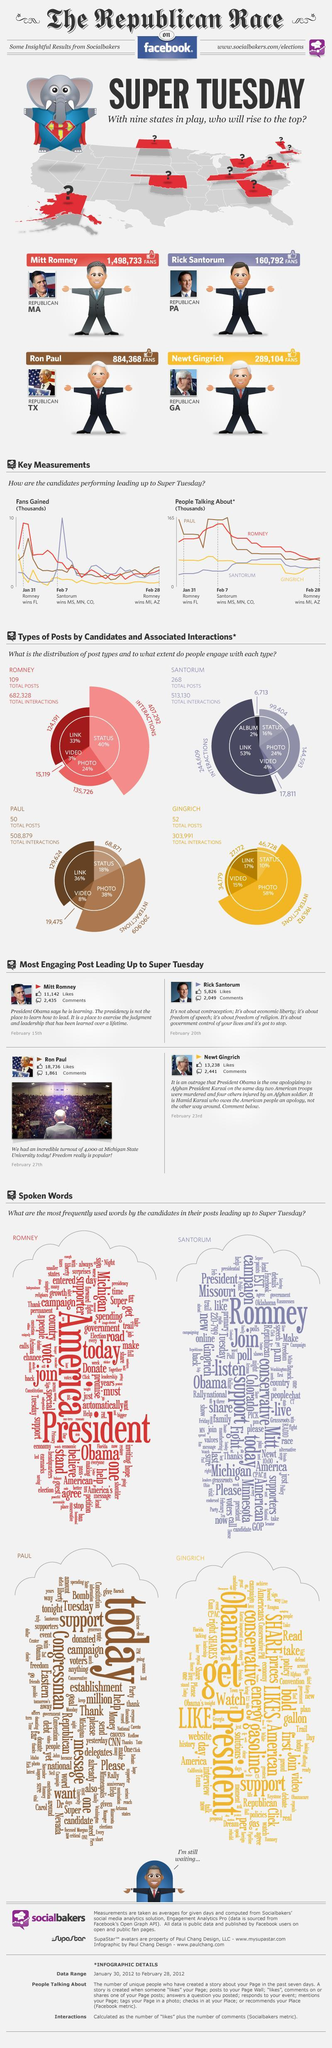Which Republican has second highest fans?
Answer the question with a short phrase. Ron Paul What was the most frequently spoken word by Rick Santorum ? Romney Who is the Republican from Pennsylvania and has the least number of fans? Rick Santorum Which candidates gained more fans than Mitt Romney in February? Rick Santorum What was the least percentage of status updates? 10% What was the number of interactions Ron Paul had through links? 129,624 What was the number of interactions Newt Gingrich had through videos? 34,179 Which candidate was mentions by people dropping in the month of February? Newt Gingrich What was the most frequently spoken word by Ron Paul? today Who was the only candidate who had an album to engage people? Rick Santorum 